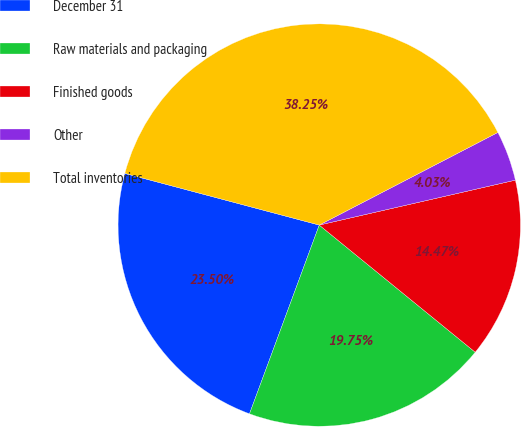Convert chart to OTSL. <chart><loc_0><loc_0><loc_500><loc_500><pie_chart><fcel>December 31<fcel>Raw materials and packaging<fcel>Finished goods<fcel>Other<fcel>Total inventories<nl><fcel>23.5%<fcel>19.75%<fcel>14.47%<fcel>4.03%<fcel>38.25%<nl></chart> 